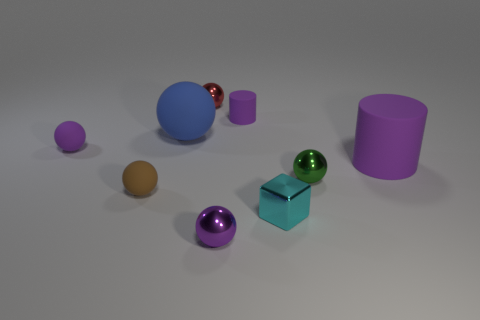What is the color of the big rubber sphere?
Your answer should be compact. Blue. Is the shape of the purple thing on the left side of the small red sphere the same as  the tiny cyan thing?
Make the answer very short. No. How many objects are small things in front of the tiny green metal object or blue metallic cubes?
Your response must be concise. 3. Are there any large blue objects that have the same shape as the brown thing?
Your answer should be very brief. Yes. The brown thing that is the same size as the cube is what shape?
Ensure brevity in your answer.  Sphere. What shape is the object behind the tiny purple rubber object on the right side of the tiny rubber sphere that is behind the small green metal thing?
Provide a short and direct response. Sphere. There is a brown rubber object; is its shape the same as the rubber object to the right of the tiny purple cylinder?
Provide a short and direct response. No. What number of small things are blue rubber things or purple objects?
Your answer should be compact. 3. Is there a cyan shiny object that has the same size as the green metal object?
Offer a very short reply. Yes. What color is the cylinder that is left of the tiny metallic sphere on the right side of the tiny purple ball that is in front of the large matte cylinder?
Keep it short and to the point. Purple. 